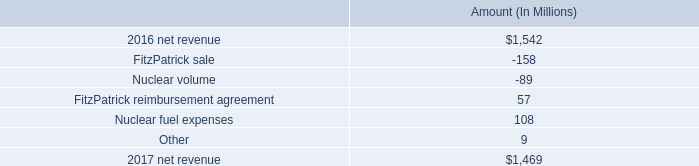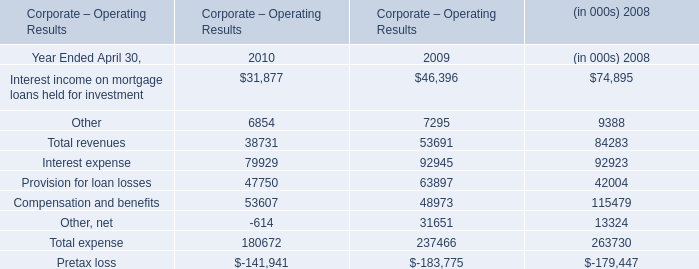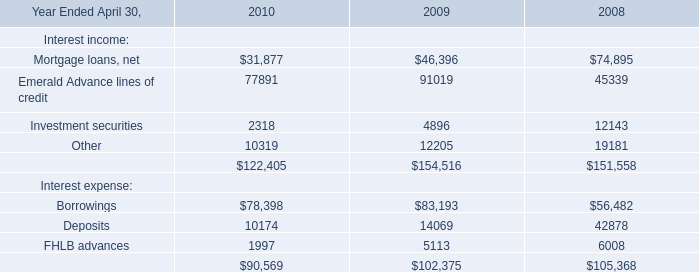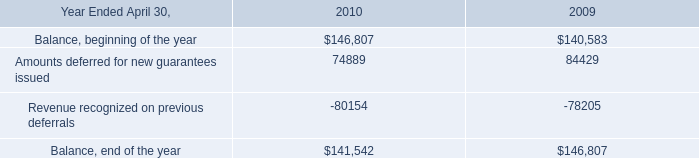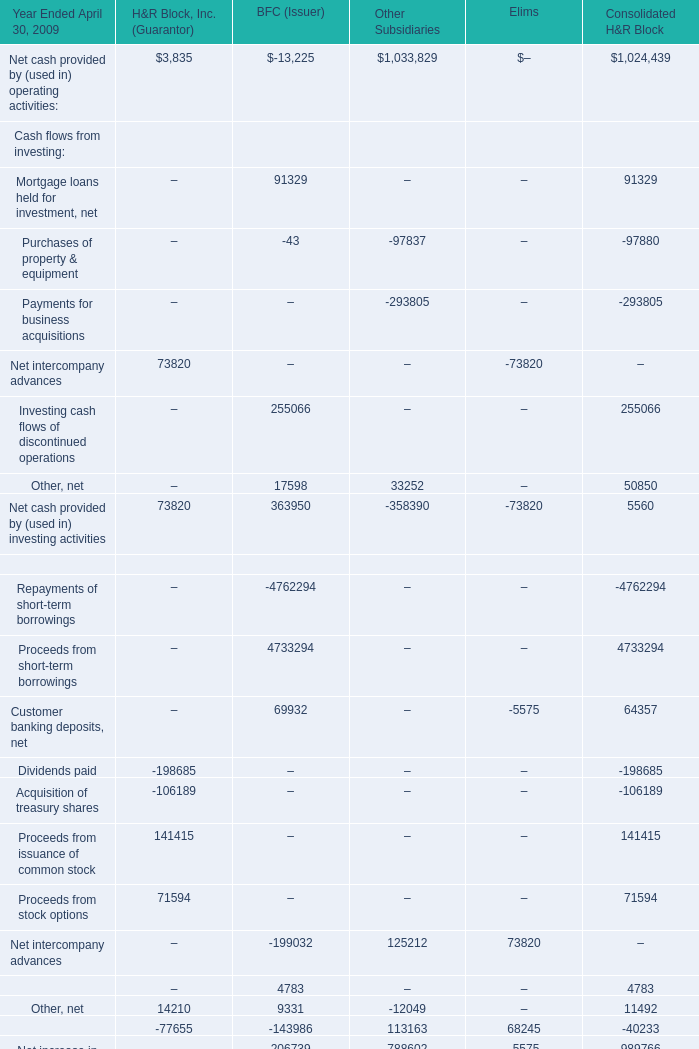what is the growth rate in net revenue in 2017? 
Computations: ((1469 - 1542) / 1542)
Answer: -0.04734. 